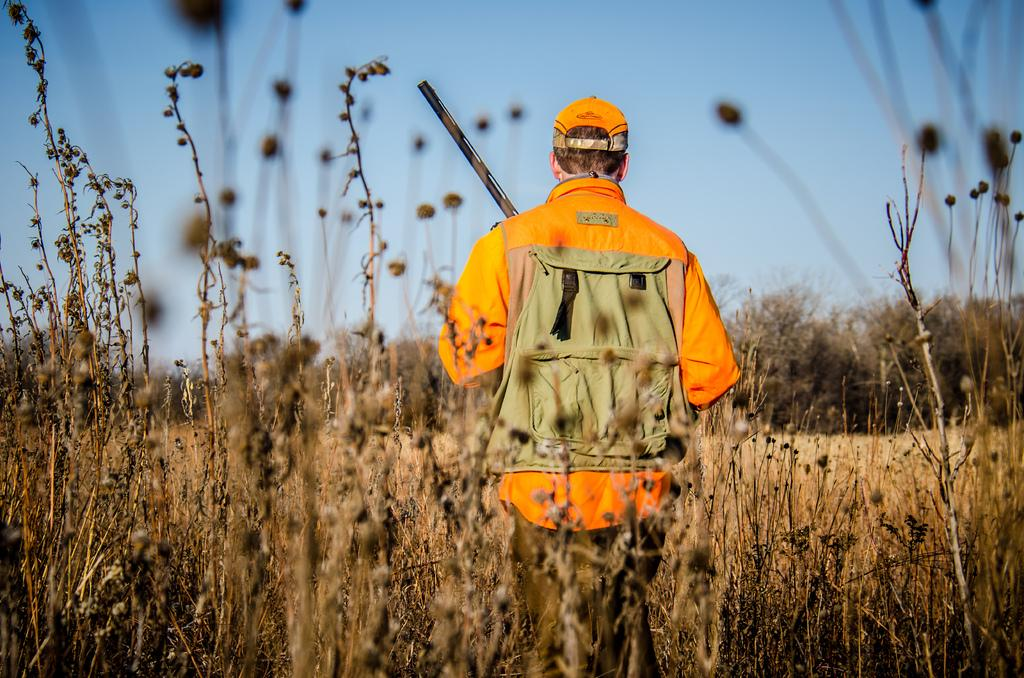What is the main subject of the image? There is a man standing in the center of the image. What is the man wearing on his head? The man is wearing a hat. What is the man carrying in the image? The man is carrying a bag. What can be seen in the background of the image? There are plants and trees in the background of the image. What is visible at the top of the image? The sky is visible at the top of the image. How many matches are visible in the image? There are no matches present in the image. What is the size of the sidewalk in the image? There is no sidewalk visible in the image. 